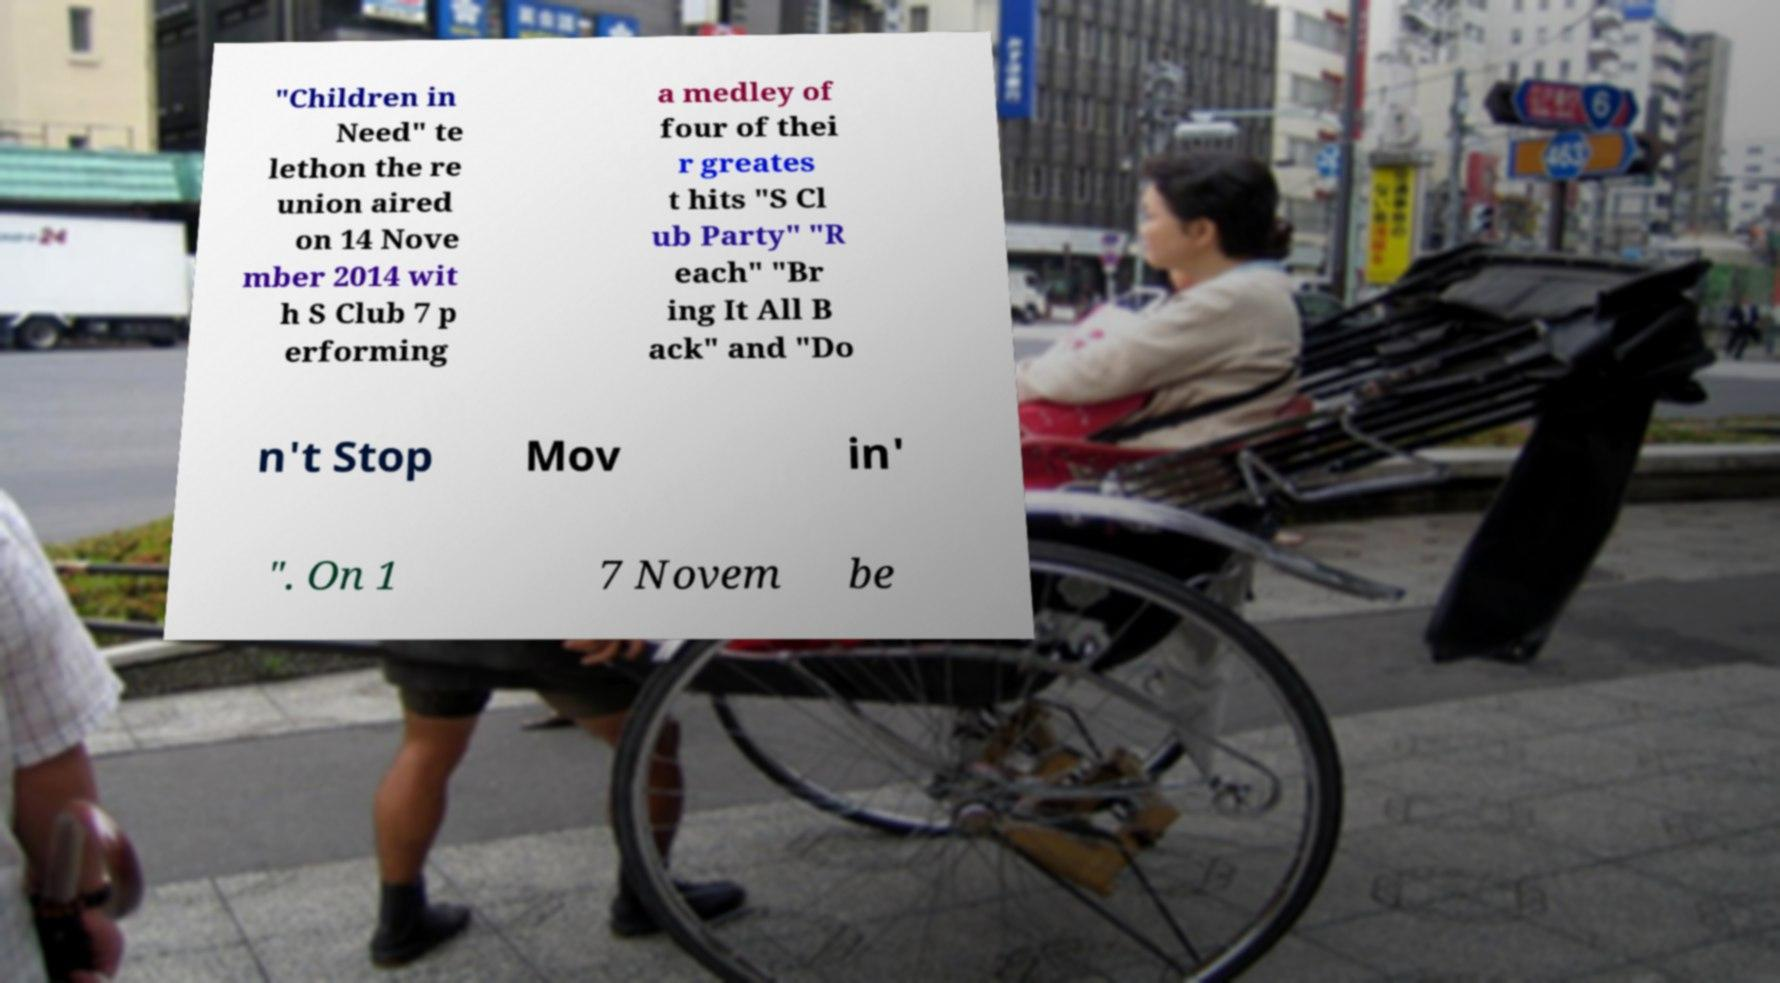What messages or text are displayed in this image? I need them in a readable, typed format. "Children in Need" te lethon the re union aired on 14 Nove mber 2014 wit h S Club 7 p erforming a medley of four of thei r greates t hits "S Cl ub Party" "R each" "Br ing It All B ack" and "Do n't Stop Mov in' ". On 1 7 Novem be 